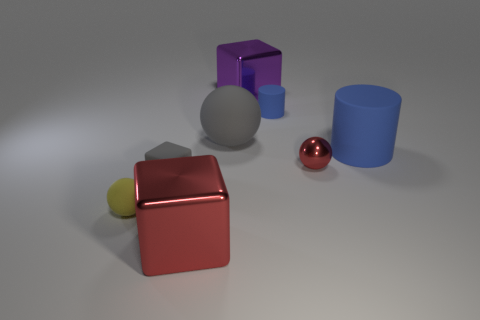Add 1 big red metallic things. How many objects exist? 9 Subtract all balls. How many objects are left? 5 Add 4 small gray blocks. How many small gray blocks are left? 5 Add 6 large rubber spheres. How many large rubber spheres exist? 7 Subtract 0 cyan cylinders. How many objects are left? 8 Subtract all tiny rubber balls. Subtract all gray rubber spheres. How many objects are left? 6 